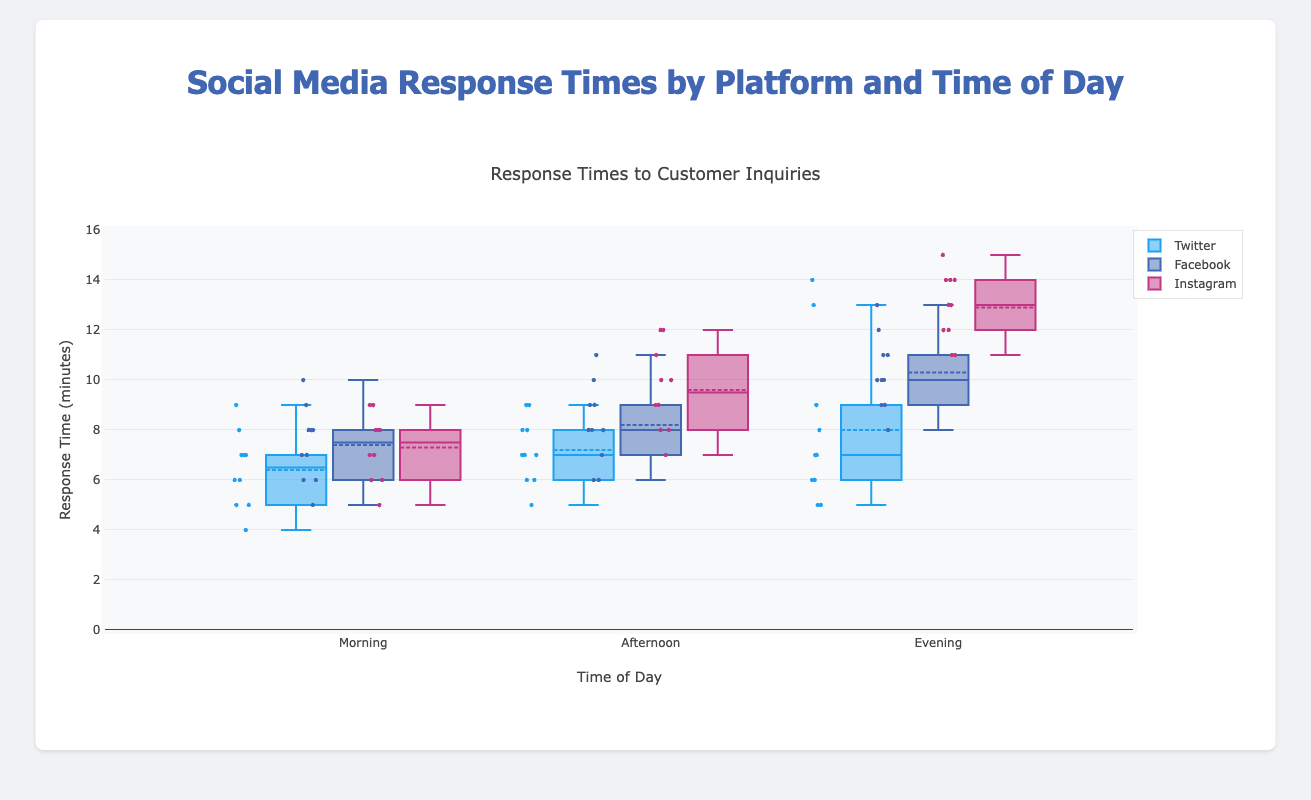What's the title of the figure? The title is located at the top of the figure and states the main topic of the plot.
Answer: Social Media Response Times by Platform and Time of Day What are the axis titles? The x-axis title is "Time of Day" and the y-axis title is "Response Time (minutes)". These titles give context to what the axis represents in the plot.
Answer: Time of Day, Response Time (minutes) Which platform has the highest median response time in the morning? To determine this, locate the median line within the box for each platform in the "Morning" category on the x-axis. The median for Instagram appears to be the highest.
Answer: Instagram What is the median response time for Twitter in the evening? The median is the line inside the box for Twitter in the "Evening" category. This is around 7 minutes.
Answer: 7 minutes Which platform shows the most variability in response times in the evening? Variability can be assessed by the length of the box and the spread of the whiskers. Facebook, with its longer whiskers and larger box, shows the most variability in the evening.
Answer: Facebook Among the platforms, which consistently has the lowest response times across all times of day? By looking at the medians across all times of day, Twitter tends to have lower medians consistently compared to Facebook and Instagram.
Answer: Twitter What range of response times does Facebook show in the afternoon? The range can be identified by the bottom and top whiskers. For Facebook in the afternoon, this spans from 6 to 11 minutes.
Answer: 6 to 11 minutes Which time of day sees the highest variation in response times for Instagram? Variation is indicated by the spread of each box. For Instagram, the evening shows the highest variation with a larger spread between the whiskers.
Answer: Evening What is the interquartile range (IQR) of response times for Twitter in the afternoon? The IQR is the range between the first quartile (bottom of the box) and third quartile (top of the box). For Twitter in the afternoon, the IQR spans about 6 to 8 minutes, making it 8 - 6 = 2 minutes.
Answer: 2 minutes How does the median response time for Facebook in the morning compare to that in the evening? Compare the median lines in the boxes for Facebook in the morning and evening. The morning median appears lower than the evening median.
Answer: Morning median is lower than evening 